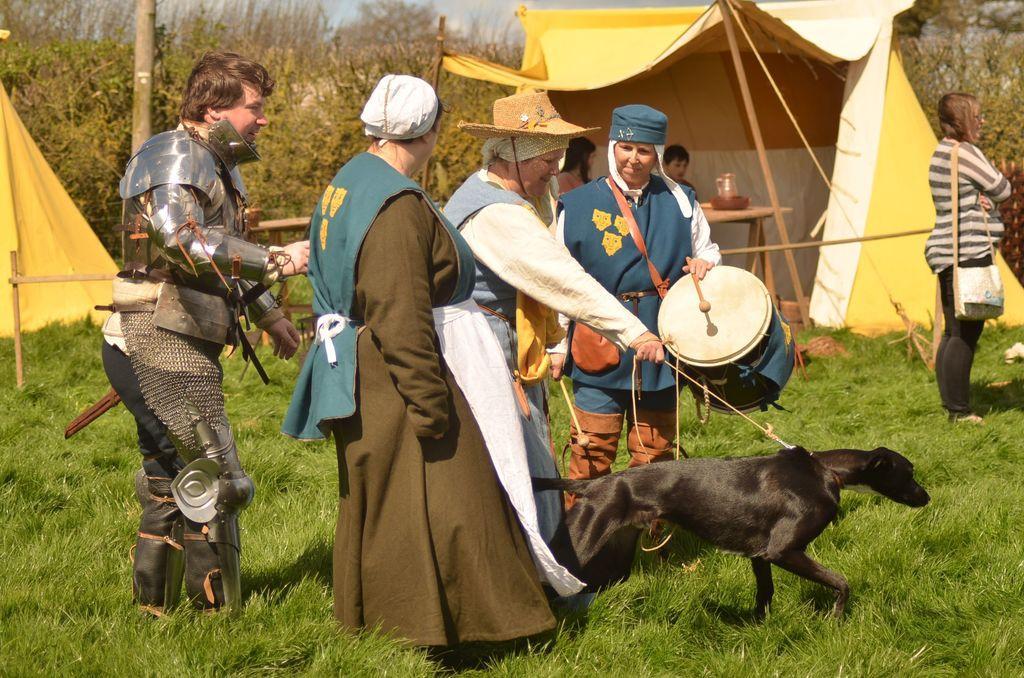In one or two sentences, can you explain what this image depicts? In this picture there are some people standing and a one guy is playing drums. There is a dog. In the background there are some people standing. We can observe some tents. There are some trees and a pole here. 